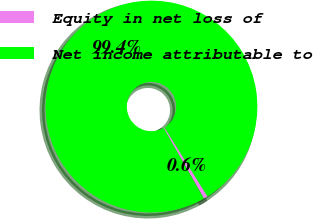Convert chart. <chart><loc_0><loc_0><loc_500><loc_500><pie_chart><fcel>Equity in net loss of<fcel>Net income attributable to<nl><fcel>0.63%<fcel>99.37%<nl></chart> 